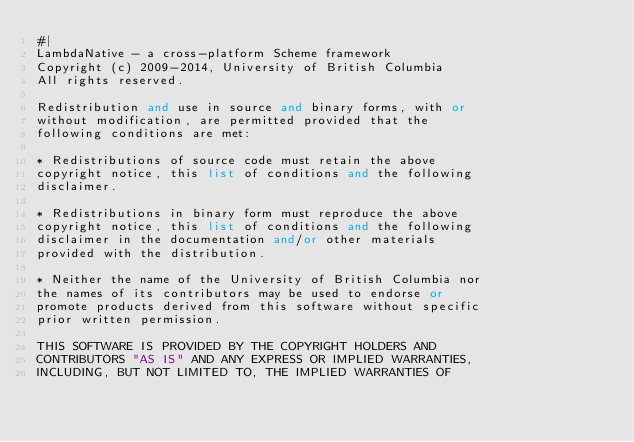Convert code to text. <code><loc_0><loc_0><loc_500><loc_500><_Scheme_>#|
LambdaNative - a cross-platform Scheme framework
Copyright (c) 2009-2014, University of British Columbia
All rights reserved.

Redistribution and use in source and binary forms, with or
without modification, are permitted provided that the
following conditions are met:

* Redistributions of source code must retain the above
copyright notice, this list of conditions and the following
disclaimer.

* Redistributions in binary form must reproduce the above
copyright notice, this list of conditions and the following
disclaimer in the documentation and/or other materials
provided with the distribution.

* Neither the name of the University of British Columbia nor
the names of its contributors may be used to endorse or
promote products derived from this software without specific
prior written permission.

THIS SOFTWARE IS PROVIDED BY THE COPYRIGHT HOLDERS AND
CONTRIBUTORS "AS IS" AND ANY EXPRESS OR IMPLIED WARRANTIES,
INCLUDING, BUT NOT LIMITED TO, THE IMPLIED WARRANTIES OF</code> 